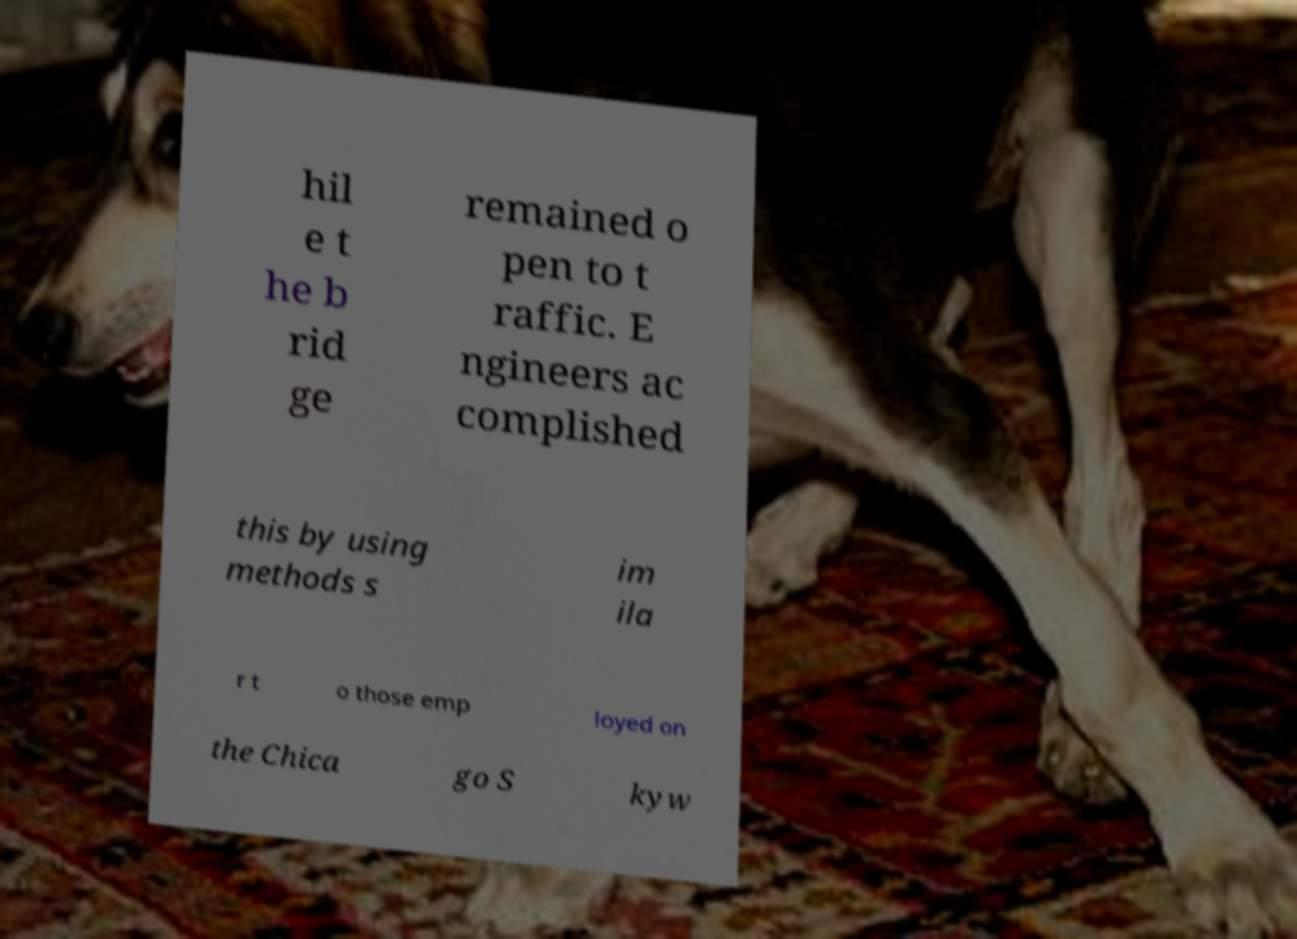There's text embedded in this image that I need extracted. Can you transcribe it verbatim? hil e t he b rid ge remained o pen to t raffic. E ngineers ac complished this by using methods s im ila r t o those emp loyed on the Chica go S kyw 